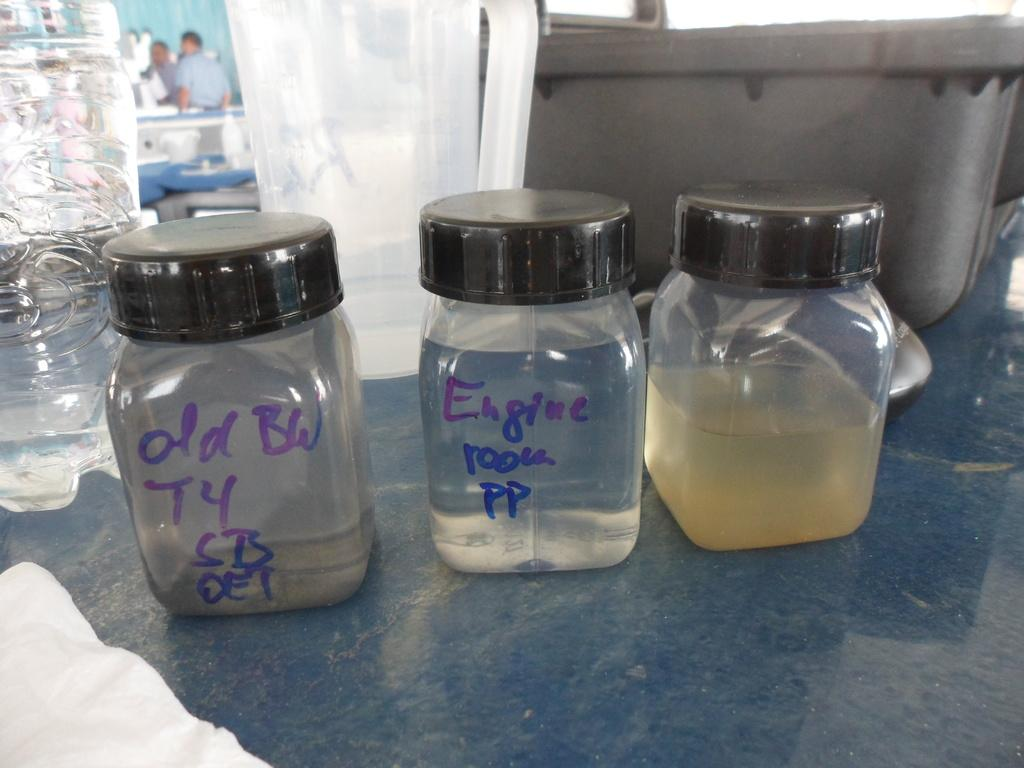<image>
Summarize the visual content of the image. a jar that says engine room pp in between two other jars 